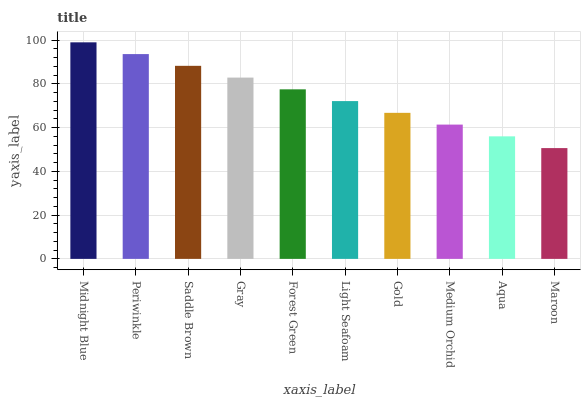Is Maroon the minimum?
Answer yes or no. Yes. Is Midnight Blue the maximum?
Answer yes or no. Yes. Is Periwinkle the minimum?
Answer yes or no. No. Is Periwinkle the maximum?
Answer yes or no. No. Is Midnight Blue greater than Periwinkle?
Answer yes or no. Yes. Is Periwinkle less than Midnight Blue?
Answer yes or no. Yes. Is Periwinkle greater than Midnight Blue?
Answer yes or no. No. Is Midnight Blue less than Periwinkle?
Answer yes or no. No. Is Forest Green the high median?
Answer yes or no. Yes. Is Light Seafoam the low median?
Answer yes or no. Yes. Is Gold the high median?
Answer yes or no. No. Is Periwinkle the low median?
Answer yes or no. No. 